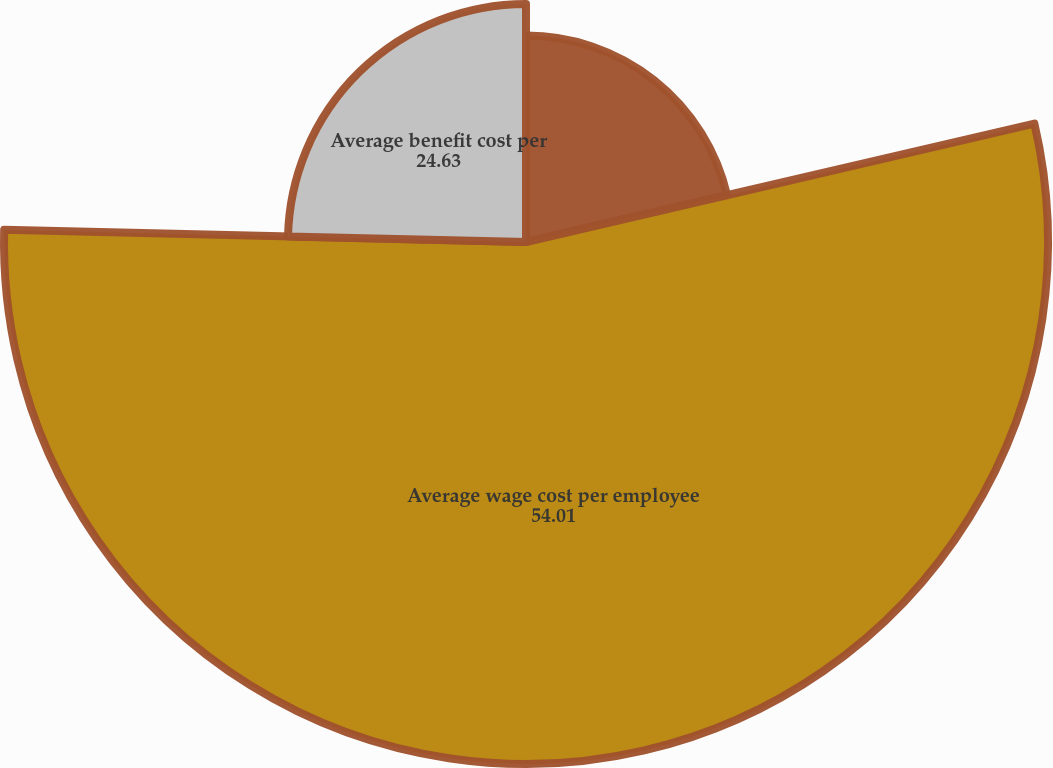Convert chart to OTSL. <chart><loc_0><loc_0><loc_500><loc_500><pie_chart><fcel>Average number of employees<fcel>Average wage cost per employee<fcel>Average benefit cost per<nl><fcel>21.36%<fcel>54.01%<fcel>24.63%<nl></chart> 